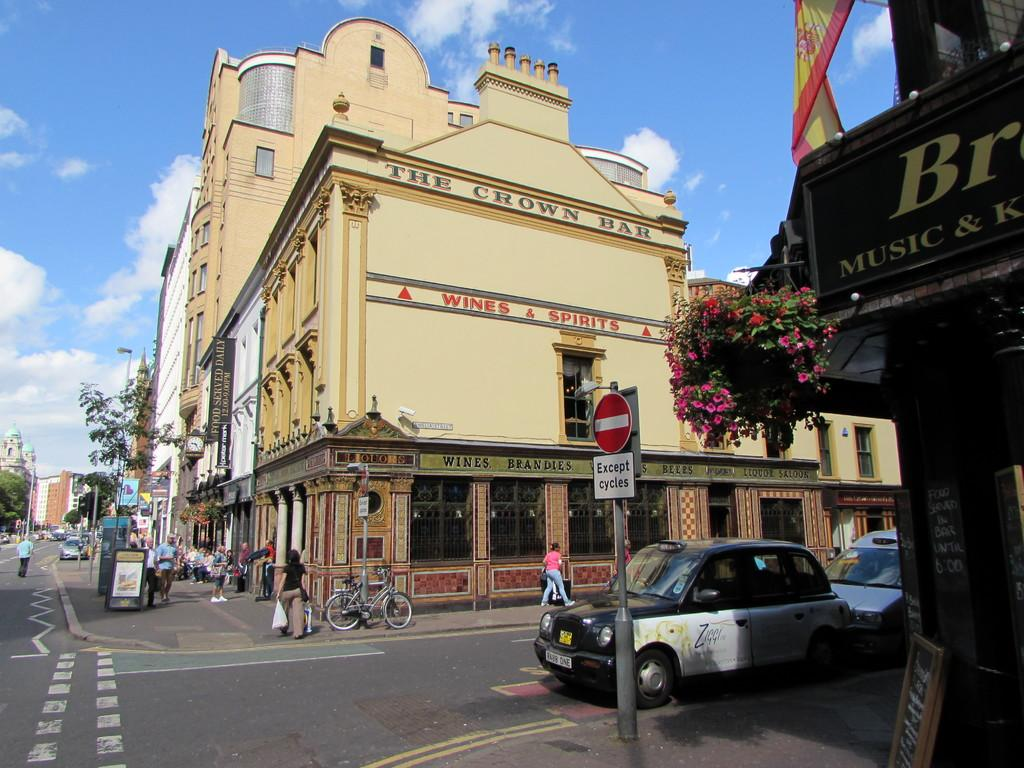Provide a one-sentence caption for the provided image. Streets full of people and cars with a crown bar. 